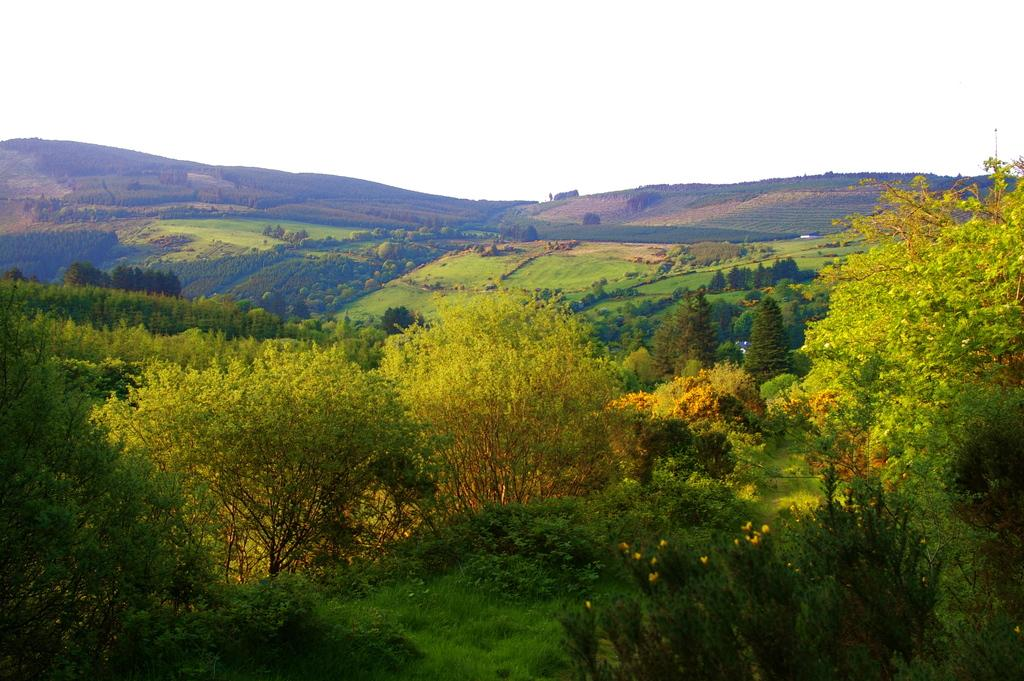What is located in the center of the image? There are trees in the center of the image. What can be seen in the background of the image? Hills and the sky are visible in the background of the image. What type of vegetation is at the bottom of the image? There is grass at the bottom of the image. What type of powder is being used to stop the trees from growing in the image? There is no mention of any powder or stopping the trees from growing in the image. The trees are simply depicted as they are. 